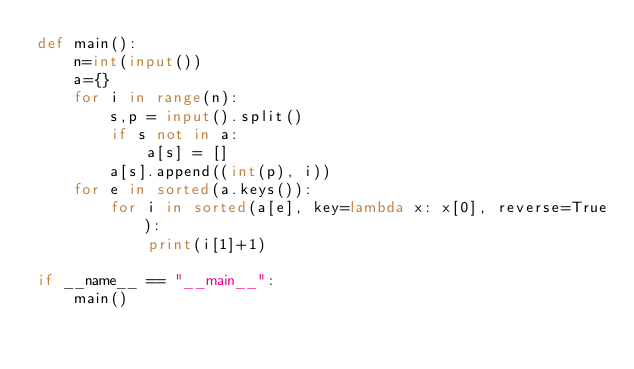<code> <loc_0><loc_0><loc_500><loc_500><_Python_>def main():
    n=int(input())
    a={}
    for i in range(n):
        s,p = input().split()
        if s not in a:
            a[s] = []
        a[s].append((int(p), i))
    for e in sorted(a.keys()):
        for i in sorted(a[e], key=lambda x: x[0], reverse=True):
            print(i[1]+1)
    
if __name__ == "__main__":
    main()</code> 